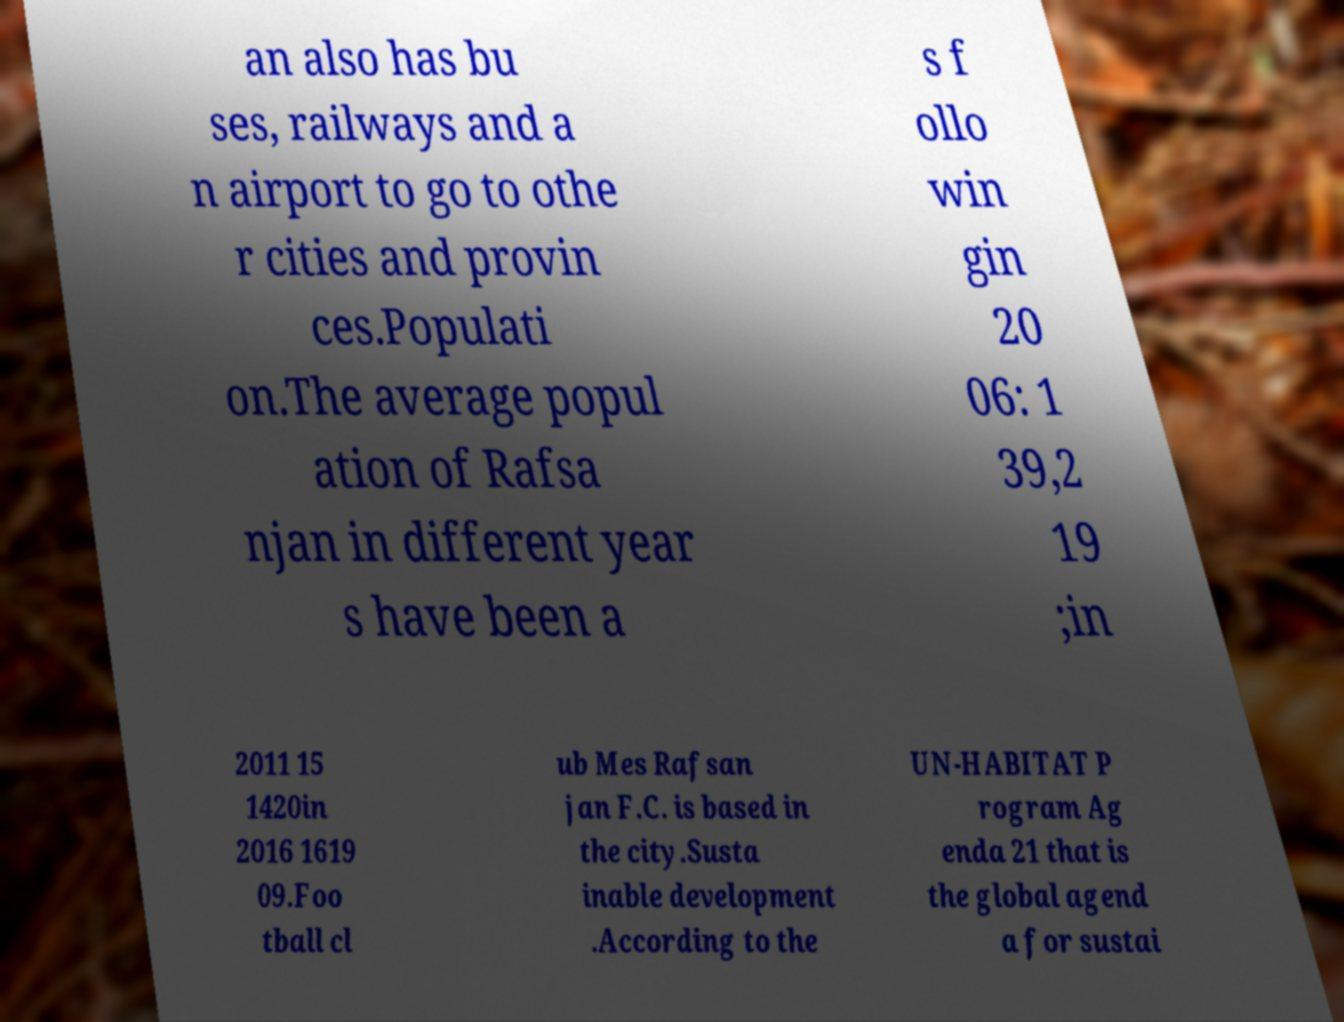Could you assist in decoding the text presented in this image and type it out clearly? an also has bu ses, railways and a n airport to go to othe r cities and provin ces.Populati on.The average popul ation of Rafsa njan in different year s have been a s f ollo win gin 20 06: 1 39,2 19 ;in 2011 15 1420in 2016 1619 09.Foo tball cl ub Mes Rafsan jan F.C. is based in the city.Susta inable development .According to the UN-HABITAT P rogram Ag enda 21 that is the global agend a for sustai 